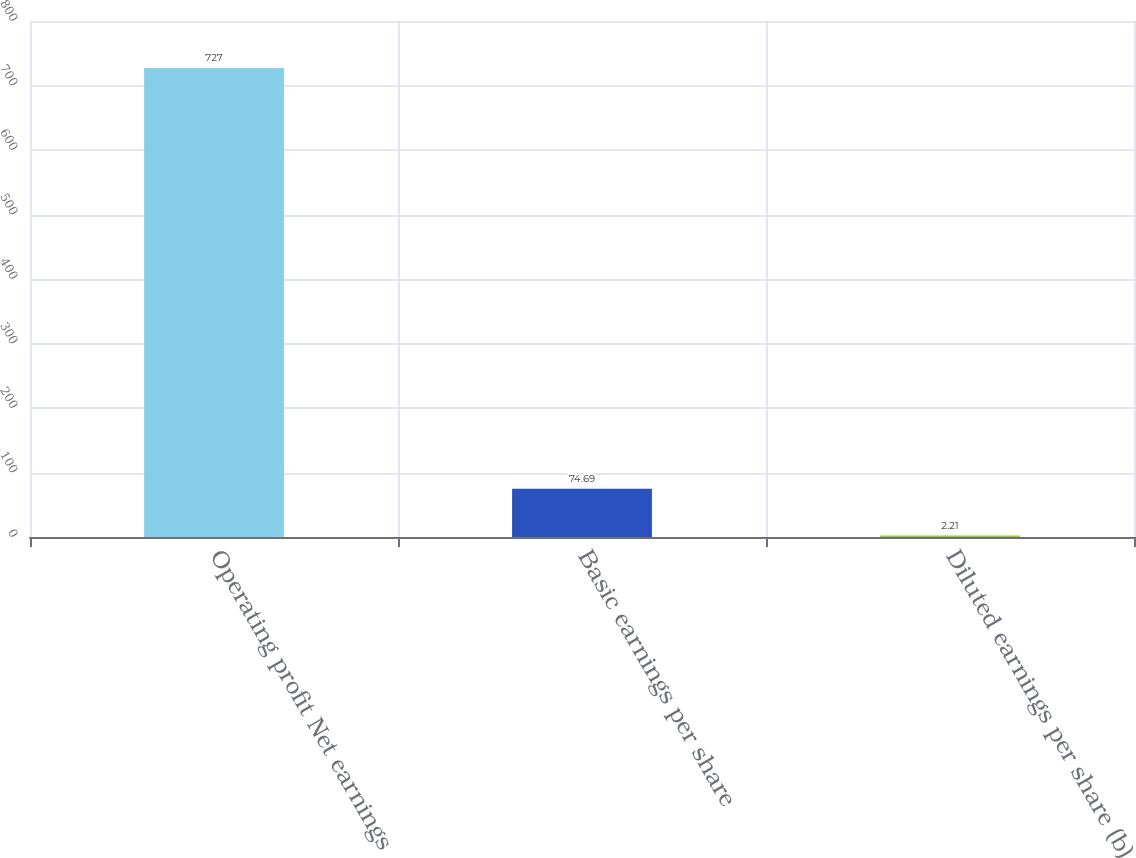Convert chart to OTSL. <chart><loc_0><loc_0><loc_500><loc_500><bar_chart><fcel>Operating profit Net earnings<fcel>Basic earnings per share<fcel>Diluted earnings per share (b)<nl><fcel>727<fcel>74.69<fcel>2.21<nl></chart> 